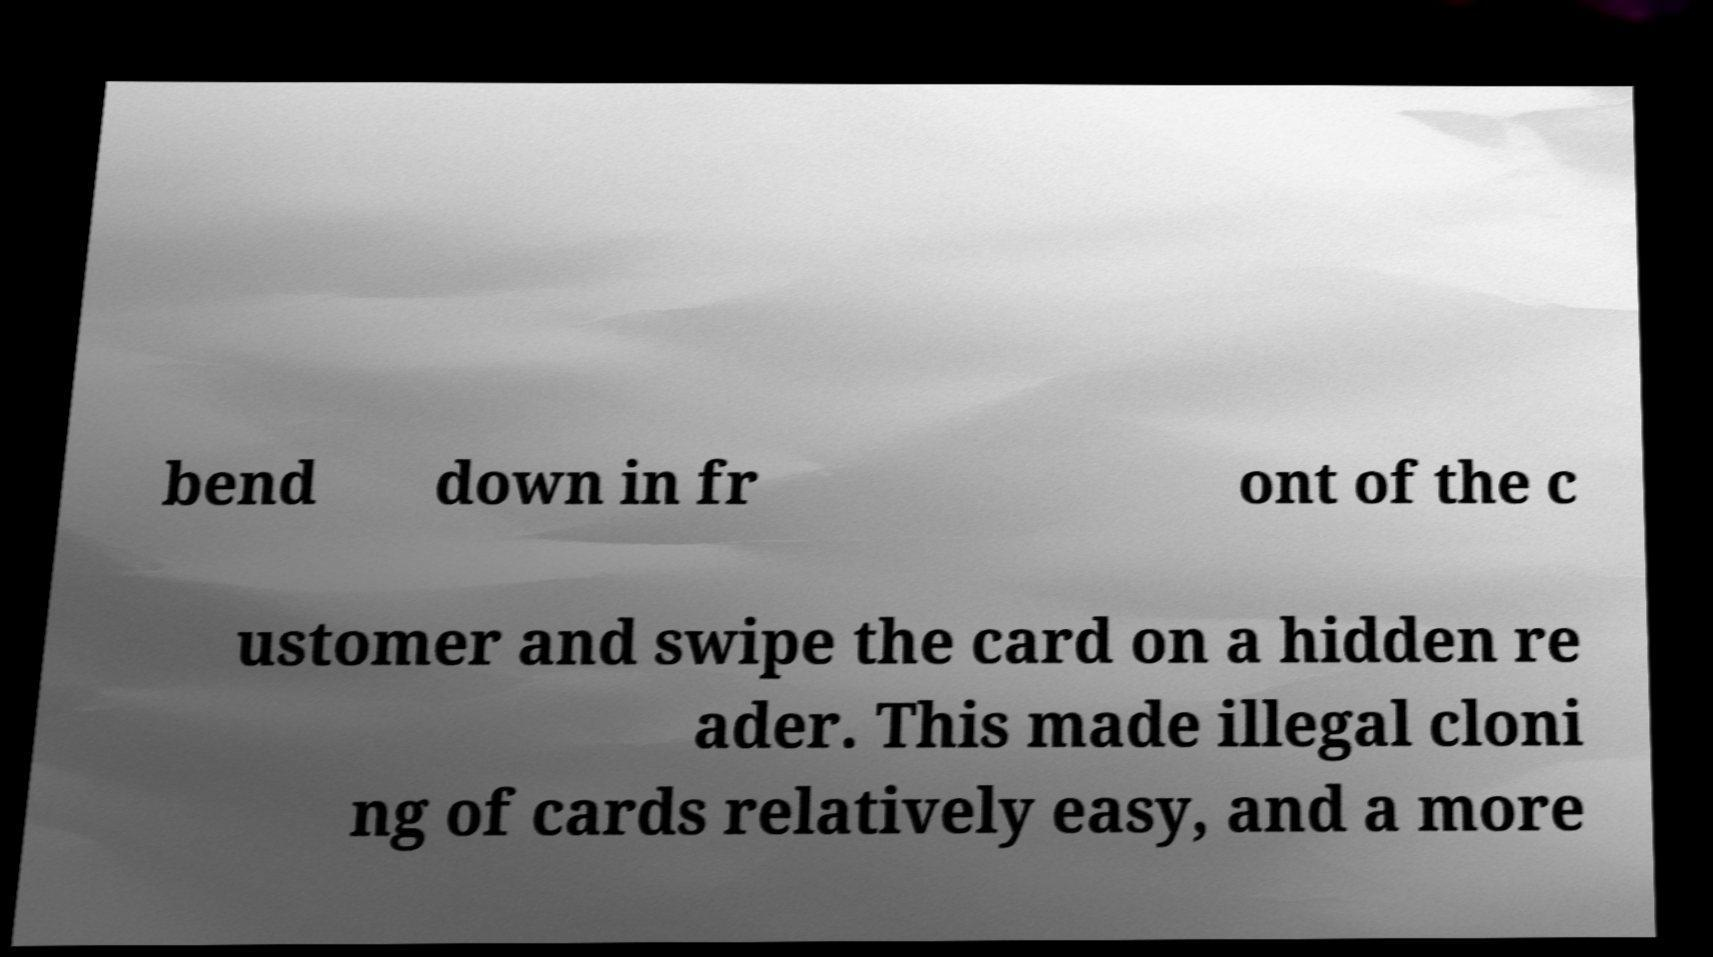Please identify and transcribe the text found in this image. bend down in fr ont of the c ustomer and swipe the card on a hidden re ader. This made illegal cloni ng of cards relatively easy, and a more 